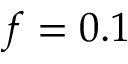<formula> <loc_0><loc_0><loc_500><loc_500>f = 0 . 1</formula> 